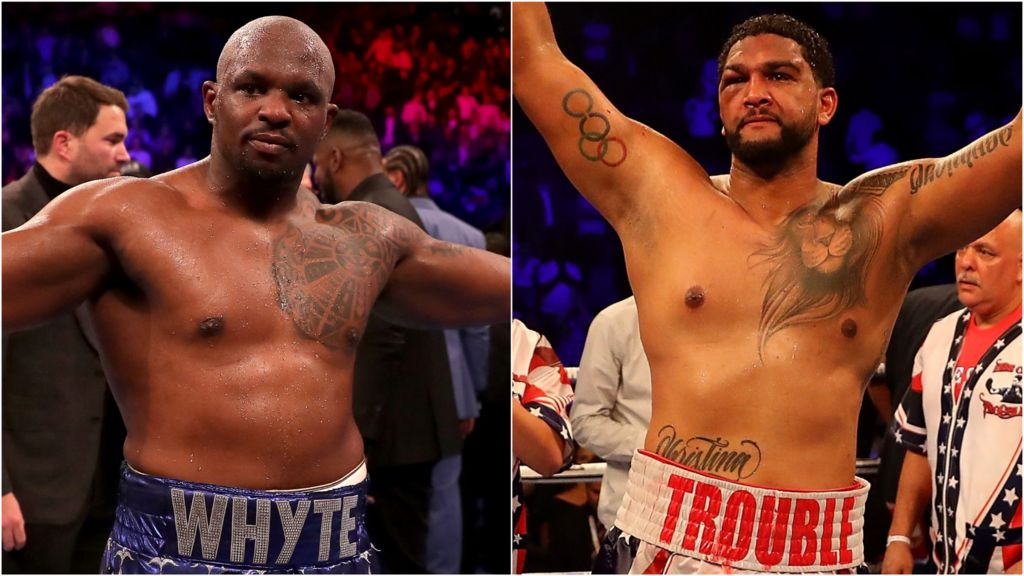Considering the tattoos, physiques, and expressions of the boxers, as well as the words on their trunks, what might be the significance of these details in the context of their professional branding and public image as athletes? The tattoos, physical condition, expressions, and the words on the trunks of the boxers play a significant role in shaping their professional branding and public image within the realm of combat sports. Tattoos often serve as a form of personal expression, potentially reflecting meaningful life stories, core beliefs, or commemorating significant milestones, such as the Olympic rings tattoo which may indicate past participation in the Olympic Games. Their well-defined and muscular physiques are outward symbols of their strength, discipline, and the rigorous training necessary to excel in boxing. The intense expressions and confident postures captured in the image convey a sense of determination, readiness, and resilience, qualities that are highly valued and celebrated in athletes. Additionally, the words on their trunks, 'WHYTE' and 'TROUBLE,' likely act as personalised monikers or branding elements, a common practice in combat sports aimed at creating a memorable and marketable persona. These elements not only help in differentiating the athletes but also in building a strong fan base and ensuring recognition in a highly competitive environment. Together, these details contribute to a compelling narrative that enhances their visibility and appeal as formidable fighters. 